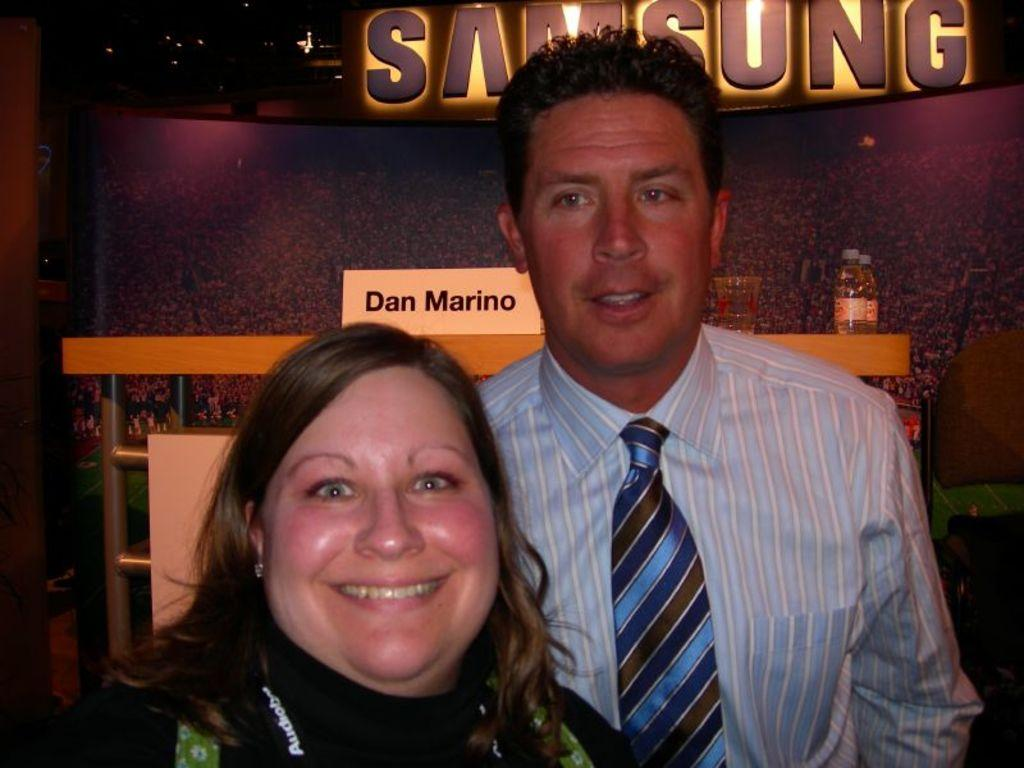Who are the people in the image? There is a man and a woman in the image. What are the man and woman doing in the image? The man and woman are standing. What can be seen on the table in the background of the image? There are bottles and a glass on the table in the background of the image. What type of voyage are the man and woman embarking on in the image? There is no indication of a voyage in the image; the man and woman are simply standing. What type of volleyball game is being played in the image? There is no volleyball game present in the image. 